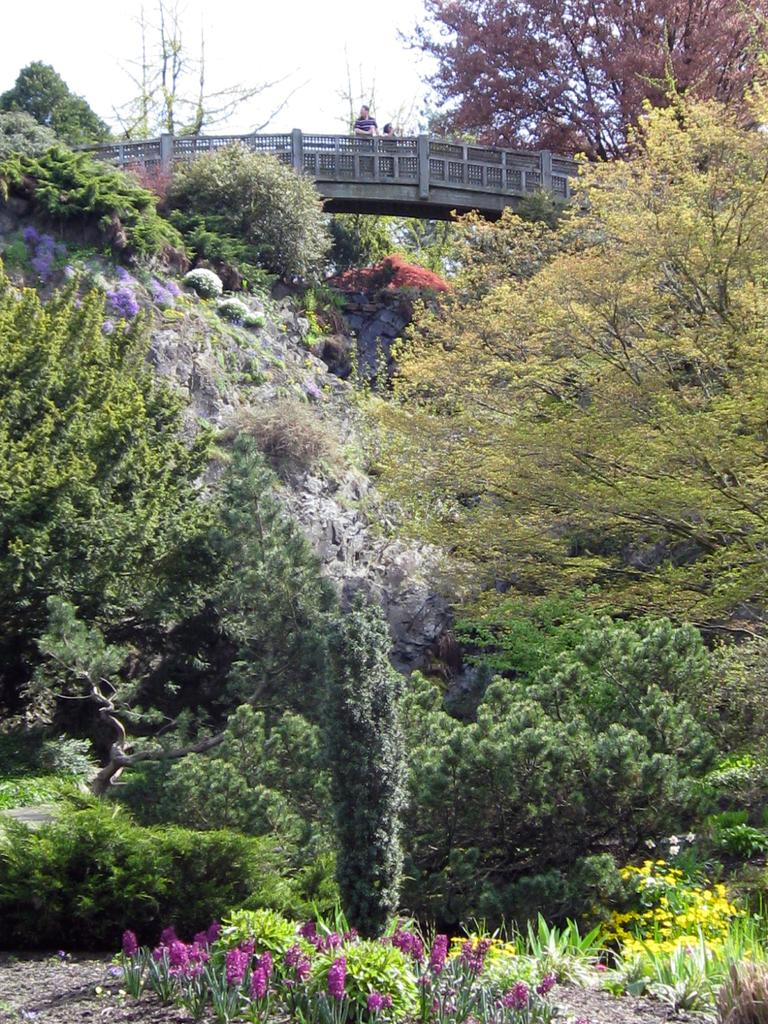What type of vegetation is present in the image? There are trees with green leaves in the image. What colors are the flowers in the image? The flowers in the image are in white and purple colors. Can you describe the people in the background of the image? There are two persons standing in the background of the image. What can be seen in the sky in the image? The sky is visible in the image, and it is in white color. What type of shoes are the trees wearing in the image? Trees do not wear shoes, as they are plants and not people. 